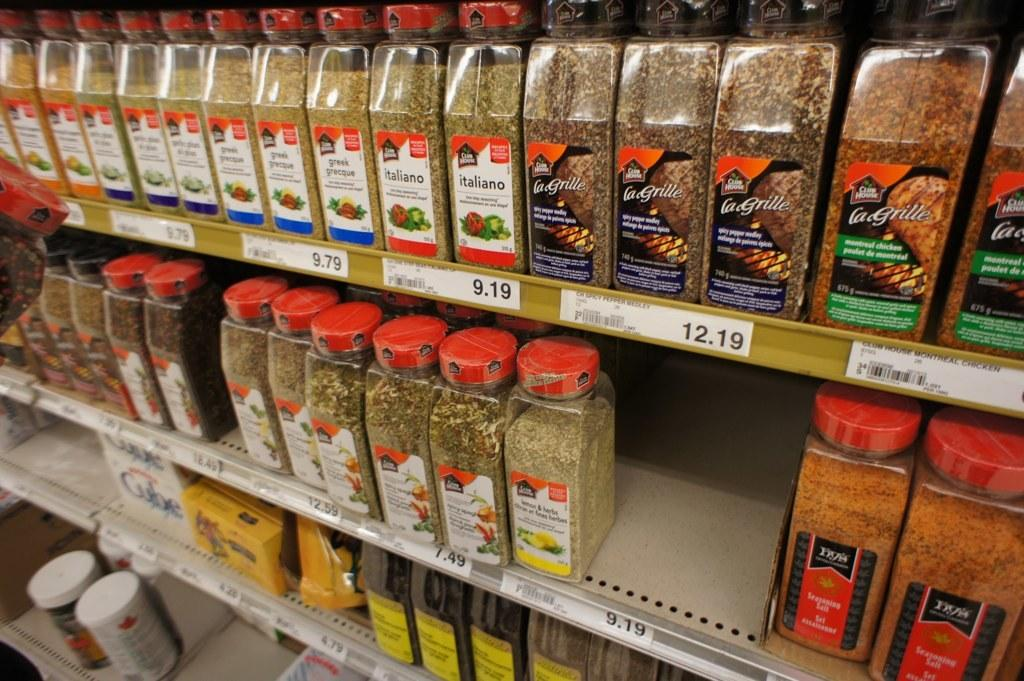<image>
Summarize the visual content of the image. Spices displayed on a rack, some for 7.49 and others for 12.19 